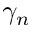<formula> <loc_0><loc_0><loc_500><loc_500>\gamma _ { n }</formula> 